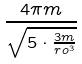Convert formula to latex. <formula><loc_0><loc_0><loc_500><loc_500>\frac { 4 \pi m } { \sqrt { 5 \cdot \frac { 3 m } { r o ^ { 3 } } } }</formula> 